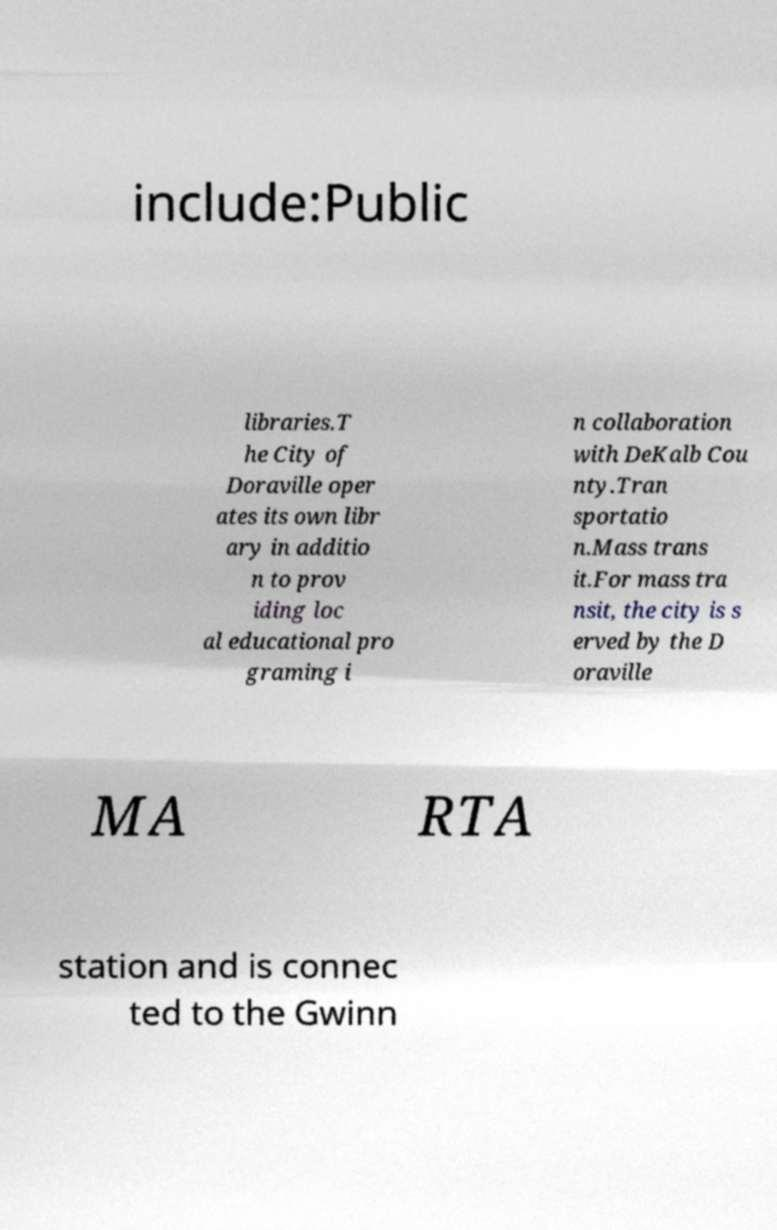For documentation purposes, I need the text within this image transcribed. Could you provide that? include:Public libraries.T he City of Doraville oper ates its own libr ary in additio n to prov iding loc al educational pro graming i n collaboration with DeKalb Cou nty.Tran sportatio n.Mass trans it.For mass tra nsit, the city is s erved by the D oraville MA RTA station and is connec ted to the Gwinn 